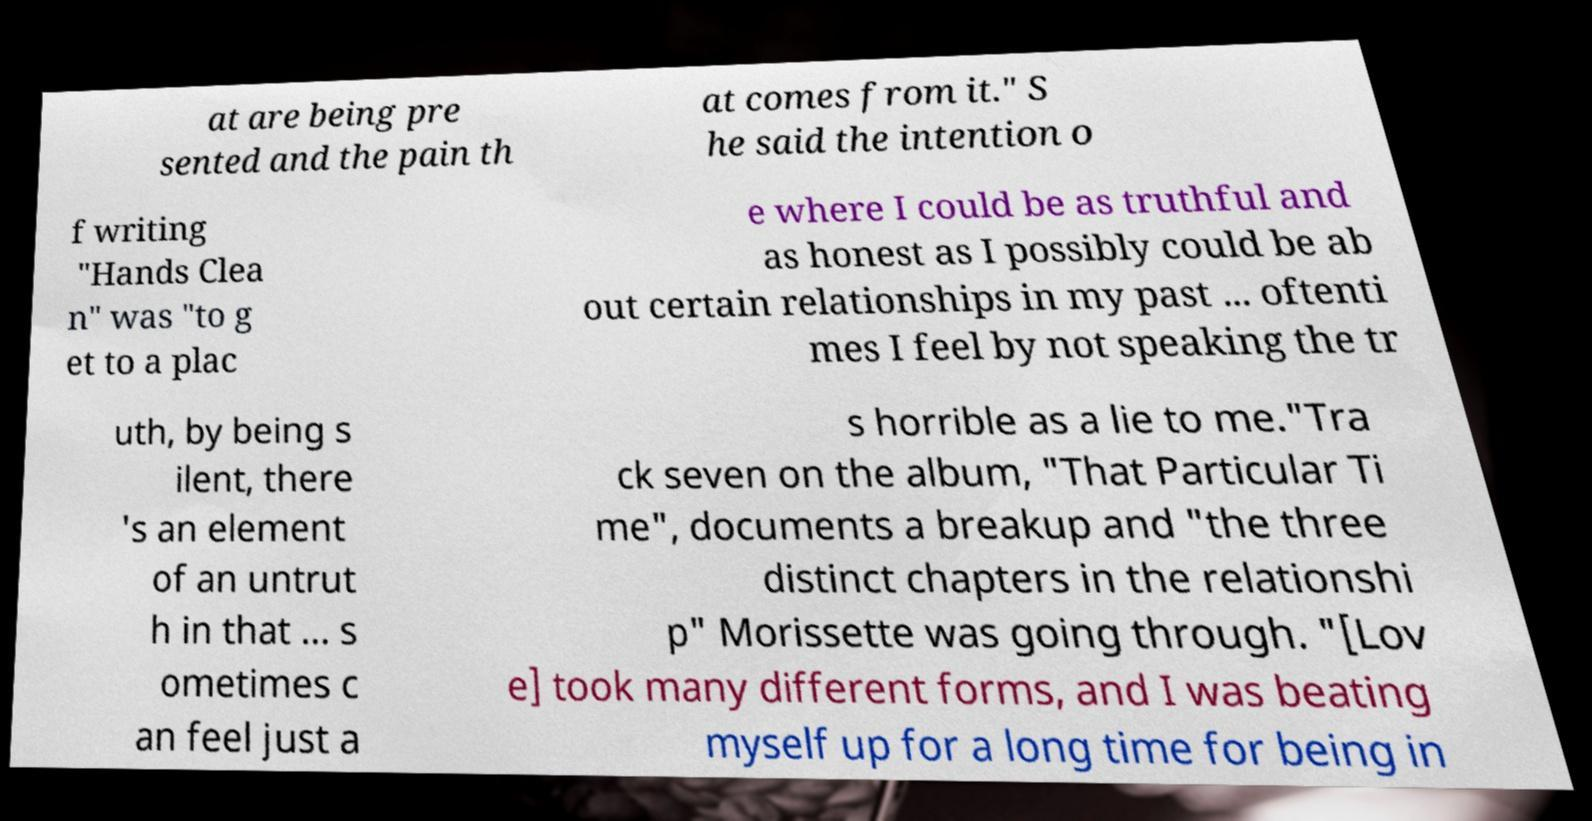Could you assist in decoding the text presented in this image and type it out clearly? at are being pre sented and the pain th at comes from it." S he said the intention o f writing "Hands Clea n" was "to g et to a plac e where I could be as truthful and as honest as I possibly could be ab out certain relationships in my past ... oftenti mes I feel by not speaking the tr uth, by being s ilent, there 's an element of an untrut h in that ... s ometimes c an feel just a s horrible as a lie to me."Tra ck seven on the album, "That Particular Ti me", documents a breakup and "the three distinct chapters in the relationshi p" Morissette was going through. "[Lov e] took many different forms, and I was beating myself up for a long time for being in 